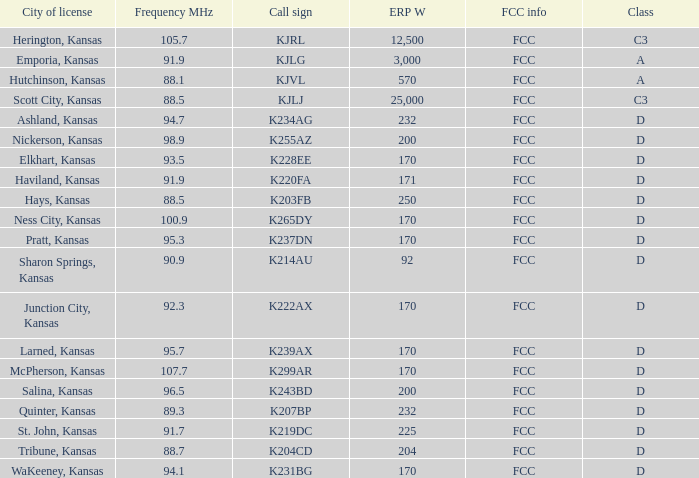Frequency MHz of 88.7 had what average erp w? 204.0. 